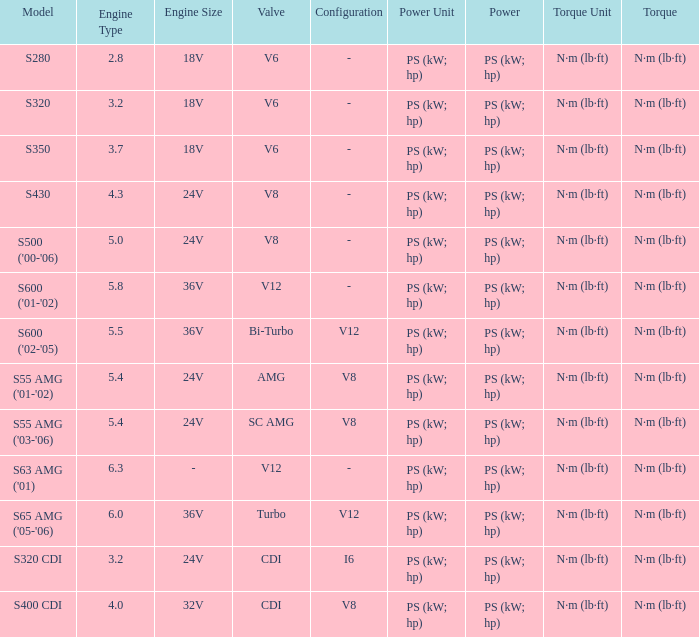Which Engine has a Model of s320 cdi? 3.2 24V CDI. 